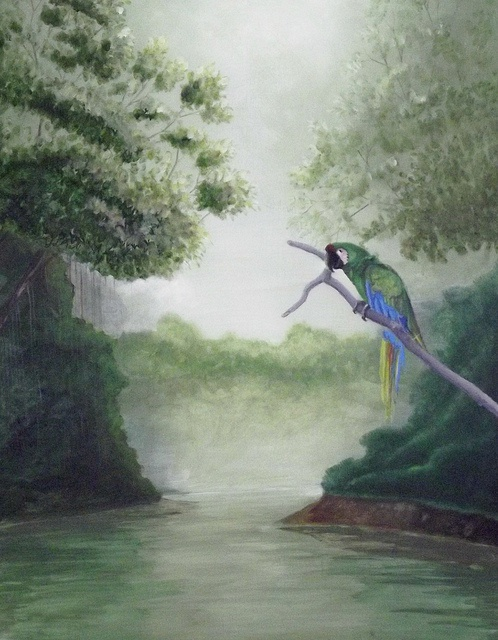Describe the objects in this image and their specific colors. I can see a bird in gray and olive tones in this image. 